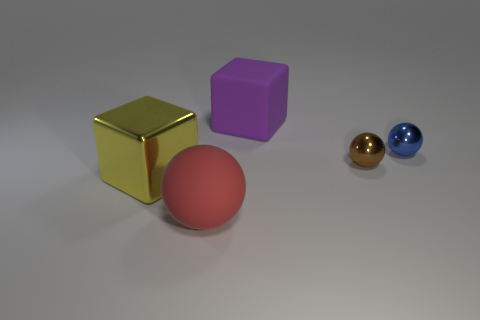Which of the objects in the image appears to have the smoothest surface? The object with the smoothest surface appears to be the gold-colored cube due to its reflective properties and sharp edges indicating a smooth texture. 